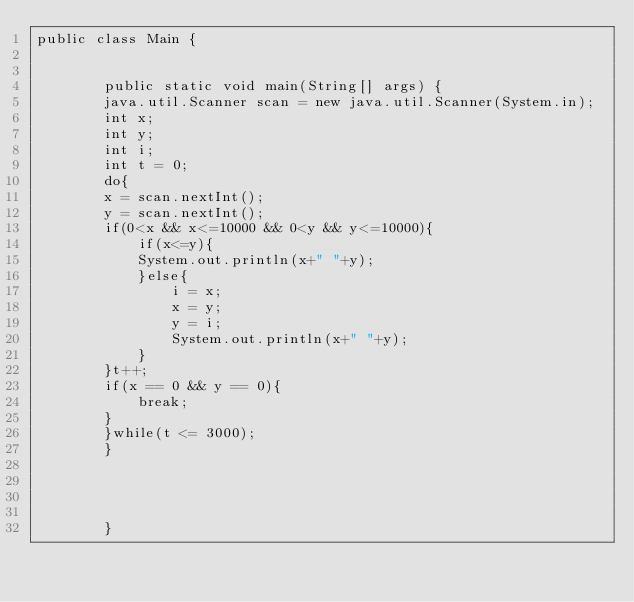Convert code to text. <code><loc_0><loc_0><loc_500><loc_500><_Java_>public class Main {
			
				
		public static void main(String[] args) {
		java.util.Scanner scan = new java.util.Scanner(System.in);
		int x;
		int y;
		int i;
		int t = 0;
		do{
		x = scan.nextInt();
		y = scan.nextInt();
		if(0<x && x<=10000 && 0<y && y<=10000){
			if(x<=y){
			System.out.println(x+" "+y);
			}else{
				i = x;
				x = y;
				y = i;
				System.out.println(x+" "+y);
			}
		}t++;
		if(x == 0 && y == 0){
			break;
		}
		}while(t <= 3000);
		}
		
					
					
					
		}</code> 